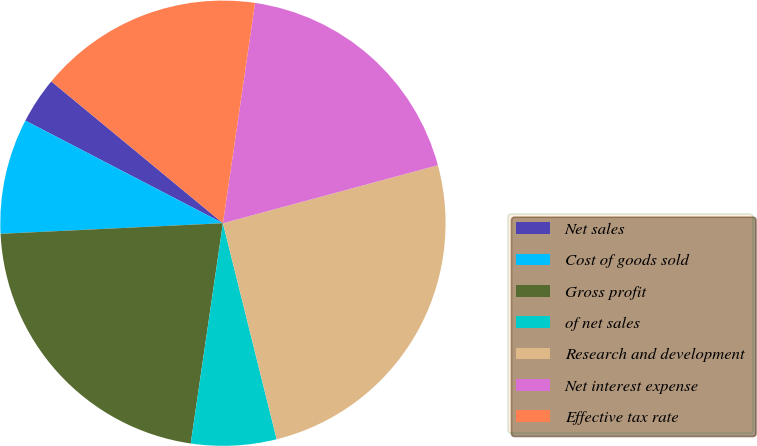<chart> <loc_0><loc_0><loc_500><loc_500><pie_chart><fcel>Net sales<fcel>Cost of goods sold<fcel>Gross profit<fcel>of net sales<fcel>Research and development<fcel>Net interest expense<fcel>Effective tax rate<nl><fcel>3.37%<fcel>8.38%<fcel>21.93%<fcel>6.19%<fcel>25.31%<fcel>18.5%<fcel>16.31%<nl></chart> 